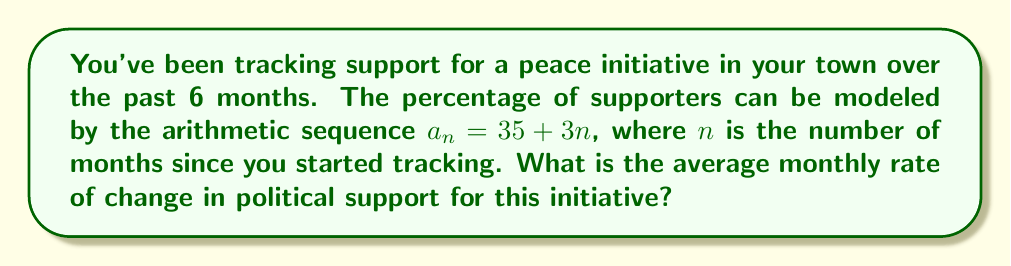Can you solve this math problem? Let's approach this step-by-step:

1) In an arithmetic sequence, the rate of change is constant and is equal to the common difference between consecutive terms.

2) The given sequence is $a_n = 35 + 3n$

3) To find the common difference, we can:
   a) Calculate $a_{n+1} - a_n$:
      $a_{n+1} = 35 + 3(n+1) = 35 + 3n + 3$
      $a_{n+1} - a_n = (35 + 3n + 3) - (35 + 3n) = 3$
   
   Or
   
   b) Simply observe the coefficient of $n$ in the general term, which is 3.

4) Therefore, the common difference is 3.

5) This means that the support increases by 3 percentage points each month.

6) Thus, the average monthly rate of change is 3 percentage points per month.
Answer: 3 percentage points per month 